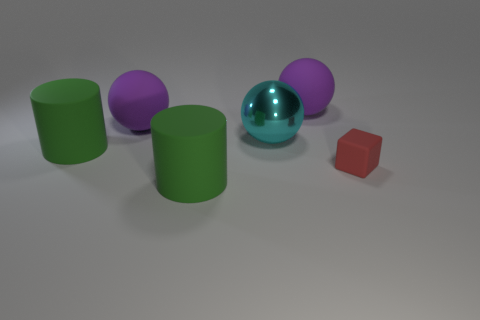Is there anything else that is made of the same material as the large cyan object?
Provide a short and direct response. No. What color is the rubber sphere in front of the sphere that is on the right side of the big shiny ball that is to the left of the red matte object?
Offer a very short reply. Purple. How many other objects are there of the same shape as the red object?
Provide a succinct answer. 0. How many objects are either small red rubber objects or purple matte spheres to the right of the cyan sphere?
Keep it short and to the point. 2. Are there any purple rubber spheres that have the same size as the metallic sphere?
Make the answer very short. Yes. Are the tiny red thing and the cyan ball made of the same material?
Keep it short and to the point. No. What number of things are red rubber cubes or rubber objects?
Offer a very short reply. 5. The red thing is what size?
Your answer should be compact. Small. Are there fewer green matte objects than balls?
Provide a succinct answer. Yes. The big rubber object that is on the right side of the large cyan ball has what shape?
Your answer should be very brief. Sphere. 